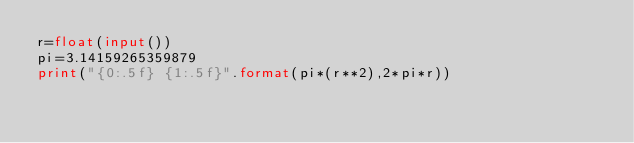Convert code to text. <code><loc_0><loc_0><loc_500><loc_500><_Python_>r=float(input())
pi=3.14159265359879
print("{0:.5f} {1:.5f}".format(pi*(r**2),2*pi*r))
</code> 